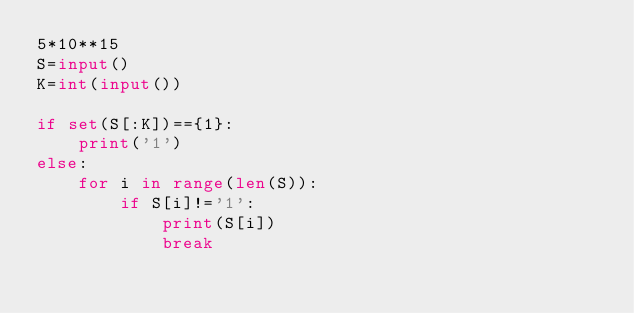<code> <loc_0><loc_0><loc_500><loc_500><_Python_>5*10**15
S=input()
K=int(input())

if set(S[:K])=={1}:
    print('1')
else:
    for i in range(len(S)):
        if S[i]!='1':
            print(S[i])
            break</code> 